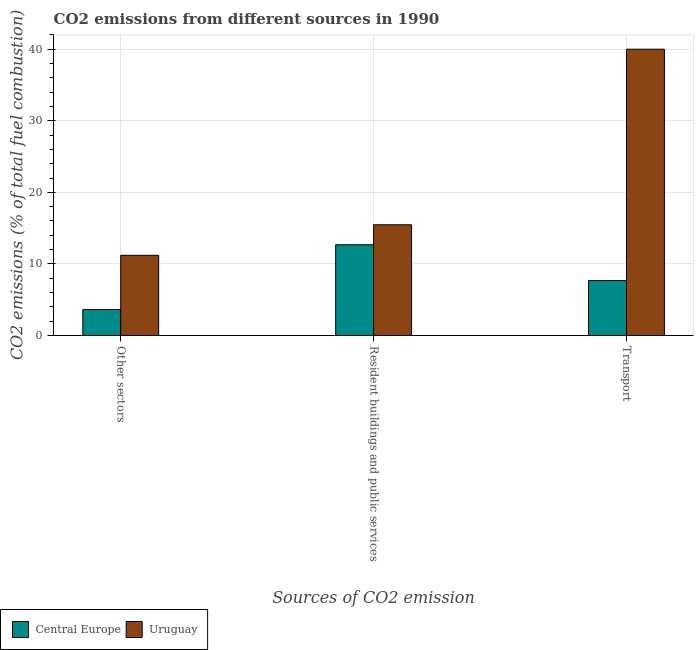How many different coloured bars are there?
Offer a very short reply. 2. How many groups of bars are there?
Give a very brief answer. 3. Are the number of bars per tick equal to the number of legend labels?
Your answer should be compact. Yes. How many bars are there on the 1st tick from the right?
Make the answer very short. 2. What is the label of the 1st group of bars from the left?
Keep it short and to the point. Other sectors. Across all countries, what is the minimum percentage of co2 emissions from transport?
Your answer should be very brief. 7.67. In which country was the percentage of co2 emissions from resident buildings and public services maximum?
Give a very brief answer. Uruguay. In which country was the percentage of co2 emissions from transport minimum?
Your response must be concise. Central Europe. What is the total percentage of co2 emissions from resident buildings and public services in the graph?
Provide a succinct answer. 28.14. What is the difference between the percentage of co2 emissions from resident buildings and public services in Central Europe and that in Uruguay?
Give a very brief answer. -2.79. What is the difference between the percentage of co2 emissions from other sectors in Uruguay and the percentage of co2 emissions from resident buildings and public services in Central Europe?
Ensure brevity in your answer.  -1.47. What is the average percentage of co2 emissions from other sectors per country?
Make the answer very short. 7.41. What is the difference between the percentage of co2 emissions from other sectors and percentage of co2 emissions from resident buildings and public services in Central Europe?
Your response must be concise. -9.06. In how many countries, is the percentage of co2 emissions from transport greater than 34 %?
Provide a succinct answer. 1. What is the ratio of the percentage of co2 emissions from other sectors in Central Europe to that in Uruguay?
Give a very brief answer. 0.32. Is the difference between the percentage of co2 emissions from transport in Central Europe and Uruguay greater than the difference between the percentage of co2 emissions from resident buildings and public services in Central Europe and Uruguay?
Ensure brevity in your answer.  No. What is the difference between the highest and the second highest percentage of co2 emissions from resident buildings and public services?
Ensure brevity in your answer.  2.79. What is the difference between the highest and the lowest percentage of co2 emissions from resident buildings and public services?
Ensure brevity in your answer.  2.79. What does the 1st bar from the left in Other sectors represents?
Make the answer very short. Central Europe. What does the 1st bar from the right in Other sectors represents?
Offer a very short reply. Uruguay. Is it the case that in every country, the sum of the percentage of co2 emissions from other sectors and percentage of co2 emissions from resident buildings and public services is greater than the percentage of co2 emissions from transport?
Ensure brevity in your answer.  No. How many bars are there?
Your answer should be compact. 6. Are all the bars in the graph horizontal?
Your response must be concise. No. How many countries are there in the graph?
Give a very brief answer. 2. Does the graph contain any zero values?
Provide a succinct answer. No. Does the graph contain grids?
Offer a terse response. Yes. How are the legend labels stacked?
Give a very brief answer. Horizontal. What is the title of the graph?
Offer a very short reply. CO2 emissions from different sources in 1990. Does "Monaco" appear as one of the legend labels in the graph?
Your answer should be very brief. No. What is the label or title of the X-axis?
Offer a terse response. Sources of CO2 emission. What is the label or title of the Y-axis?
Offer a terse response. CO2 emissions (% of total fuel combustion). What is the CO2 emissions (% of total fuel combustion) in Central Europe in Other sectors?
Provide a short and direct response. 3.62. What is the CO2 emissions (% of total fuel combustion) of Uruguay in Other sectors?
Provide a succinct answer. 11.2. What is the CO2 emissions (% of total fuel combustion) in Central Europe in Resident buildings and public services?
Provide a succinct answer. 12.67. What is the CO2 emissions (% of total fuel combustion) in Uruguay in Resident buildings and public services?
Keep it short and to the point. 15.47. What is the CO2 emissions (% of total fuel combustion) in Central Europe in Transport?
Your answer should be very brief. 7.67. Across all Sources of CO2 emission, what is the maximum CO2 emissions (% of total fuel combustion) of Central Europe?
Give a very brief answer. 12.67. Across all Sources of CO2 emission, what is the minimum CO2 emissions (% of total fuel combustion) in Central Europe?
Offer a very short reply. 3.62. What is the total CO2 emissions (% of total fuel combustion) of Central Europe in the graph?
Provide a short and direct response. 23.96. What is the total CO2 emissions (% of total fuel combustion) in Uruguay in the graph?
Make the answer very short. 66.67. What is the difference between the CO2 emissions (% of total fuel combustion) of Central Europe in Other sectors and that in Resident buildings and public services?
Offer a terse response. -9.06. What is the difference between the CO2 emissions (% of total fuel combustion) in Uruguay in Other sectors and that in Resident buildings and public services?
Ensure brevity in your answer.  -4.27. What is the difference between the CO2 emissions (% of total fuel combustion) in Central Europe in Other sectors and that in Transport?
Offer a very short reply. -4.05. What is the difference between the CO2 emissions (% of total fuel combustion) in Uruguay in Other sectors and that in Transport?
Ensure brevity in your answer.  -28.8. What is the difference between the CO2 emissions (% of total fuel combustion) of Central Europe in Resident buildings and public services and that in Transport?
Give a very brief answer. 5.01. What is the difference between the CO2 emissions (% of total fuel combustion) of Uruguay in Resident buildings and public services and that in Transport?
Keep it short and to the point. -24.53. What is the difference between the CO2 emissions (% of total fuel combustion) of Central Europe in Other sectors and the CO2 emissions (% of total fuel combustion) of Uruguay in Resident buildings and public services?
Provide a short and direct response. -11.85. What is the difference between the CO2 emissions (% of total fuel combustion) of Central Europe in Other sectors and the CO2 emissions (% of total fuel combustion) of Uruguay in Transport?
Provide a short and direct response. -36.38. What is the difference between the CO2 emissions (% of total fuel combustion) in Central Europe in Resident buildings and public services and the CO2 emissions (% of total fuel combustion) in Uruguay in Transport?
Provide a succinct answer. -27.33. What is the average CO2 emissions (% of total fuel combustion) of Central Europe per Sources of CO2 emission?
Your answer should be very brief. 7.99. What is the average CO2 emissions (% of total fuel combustion) in Uruguay per Sources of CO2 emission?
Your answer should be very brief. 22.22. What is the difference between the CO2 emissions (% of total fuel combustion) of Central Europe and CO2 emissions (% of total fuel combustion) of Uruguay in Other sectors?
Offer a terse response. -7.58. What is the difference between the CO2 emissions (% of total fuel combustion) in Central Europe and CO2 emissions (% of total fuel combustion) in Uruguay in Resident buildings and public services?
Offer a terse response. -2.79. What is the difference between the CO2 emissions (% of total fuel combustion) of Central Europe and CO2 emissions (% of total fuel combustion) of Uruguay in Transport?
Your answer should be compact. -32.33. What is the ratio of the CO2 emissions (% of total fuel combustion) of Central Europe in Other sectors to that in Resident buildings and public services?
Give a very brief answer. 0.29. What is the ratio of the CO2 emissions (% of total fuel combustion) in Uruguay in Other sectors to that in Resident buildings and public services?
Your answer should be very brief. 0.72. What is the ratio of the CO2 emissions (% of total fuel combustion) in Central Europe in Other sectors to that in Transport?
Keep it short and to the point. 0.47. What is the ratio of the CO2 emissions (% of total fuel combustion) in Uruguay in Other sectors to that in Transport?
Offer a very short reply. 0.28. What is the ratio of the CO2 emissions (% of total fuel combustion) in Central Europe in Resident buildings and public services to that in Transport?
Give a very brief answer. 1.65. What is the ratio of the CO2 emissions (% of total fuel combustion) of Uruguay in Resident buildings and public services to that in Transport?
Offer a terse response. 0.39. What is the difference between the highest and the second highest CO2 emissions (% of total fuel combustion) of Central Europe?
Offer a terse response. 5.01. What is the difference between the highest and the second highest CO2 emissions (% of total fuel combustion) in Uruguay?
Ensure brevity in your answer.  24.53. What is the difference between the highest and the lowest CO2 emissions (% of total fuel combustion) in Central Europe?
Provide a succinct answer. 9.06. What is the difference between the highest and the lowest CO2 emissions (% of total fuel combustion) in Uruguay?
Offer a terse response. 28.8. 